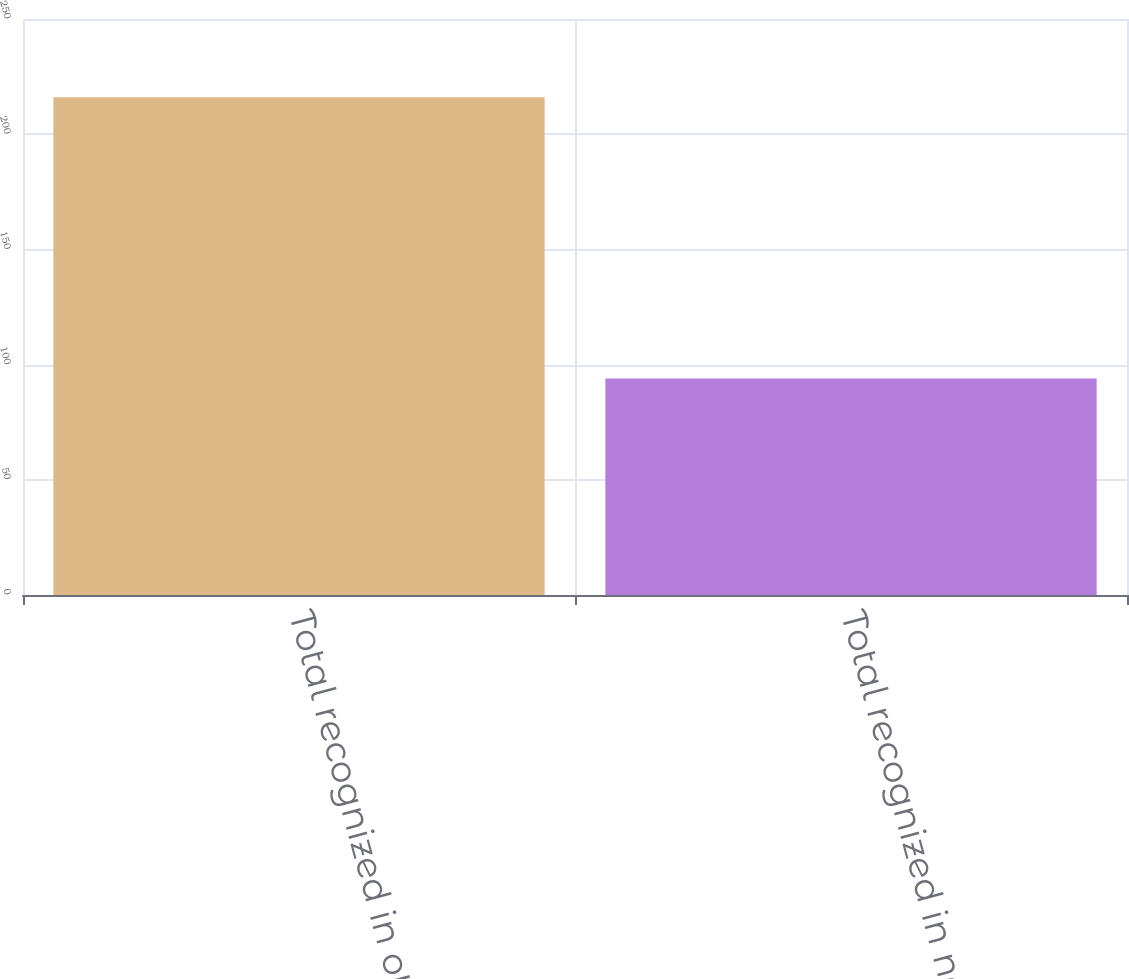<chart> <loc_0><loc_0><loc_500><loc_500><bar_chart><fcel>Total recognized in other<fcel>Total recognized in net<nl><fcel>216<fcel>94<nl></chart> 